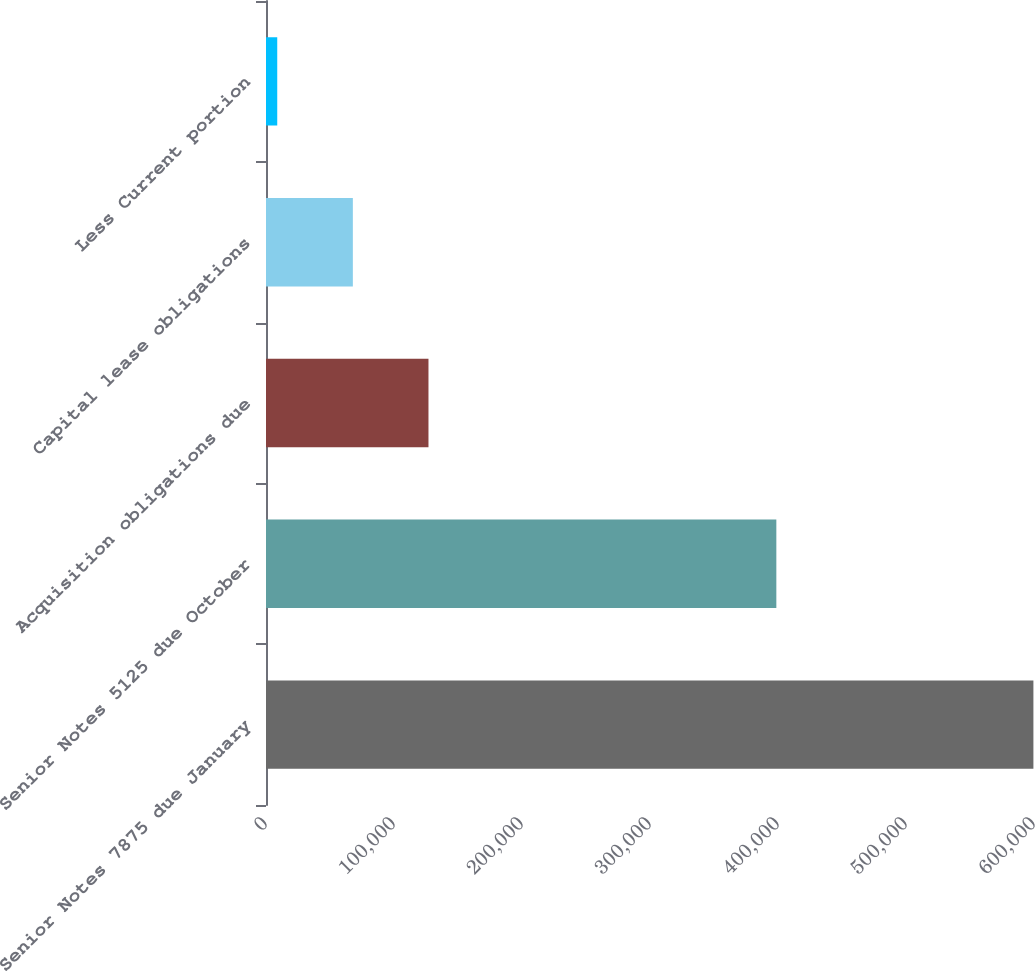<chart> <loc_0><loc_0><loc_500><loc_500><bar_chart><fcel>Senior Notes 7875 due January<fcel>Senior Notes 5125 due October<fcel>Acquisition obligations due<fcel>Capital lease obligations<fcel>Less Current portion<nl><fcel>599539<fcel>398706<fcel>126933<fcel>67857.7<fcel>8782<nl></chart> 